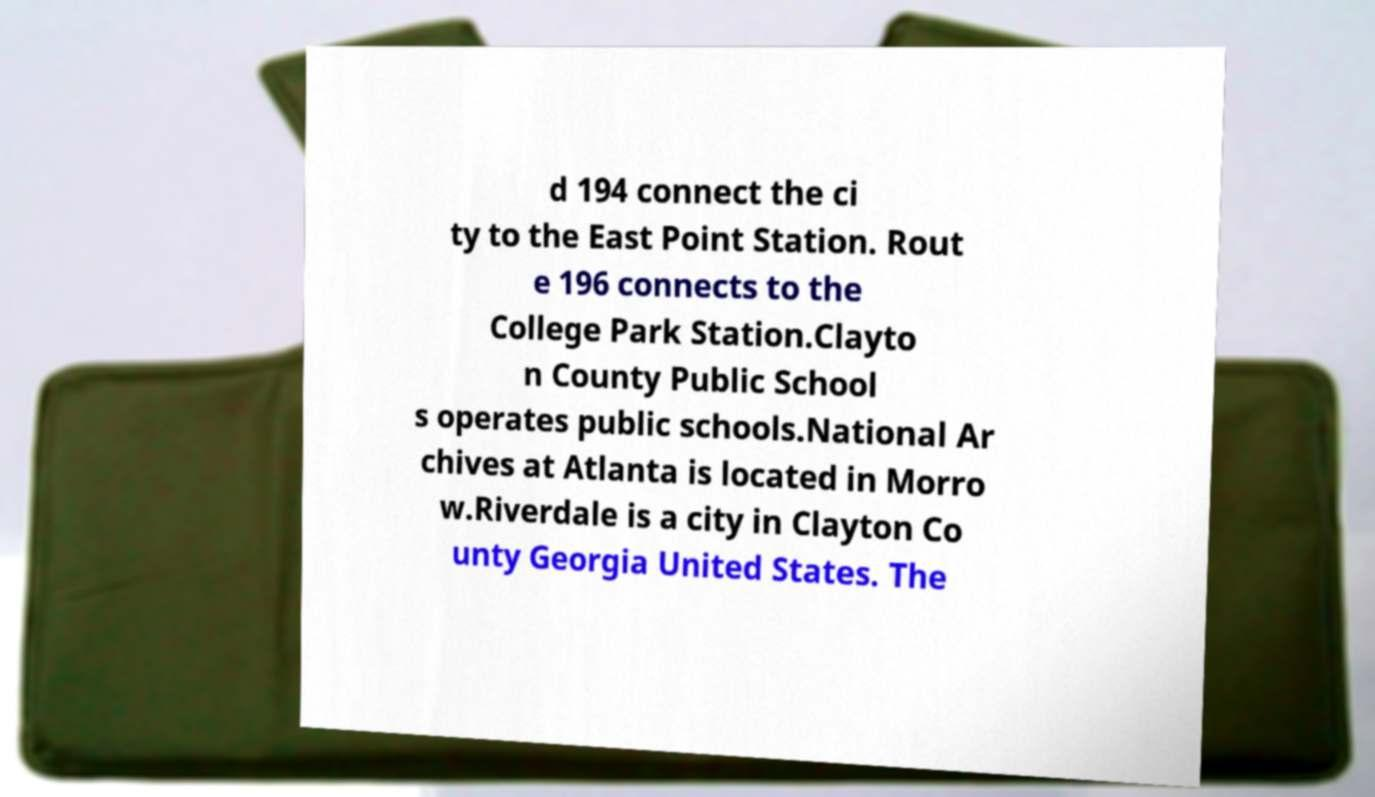For documentation purposes, I need the text within this image transcribed. Could you provide that? d 194 connect the ci ty to the East Point Station. Rout e 196 connects to the College Park Station.Clayto n County Public School s operates public schools.National Ar chives at Atlanta is located in Morro w.Riverdale is a city in Clayton Co unty Georgia United States. The 